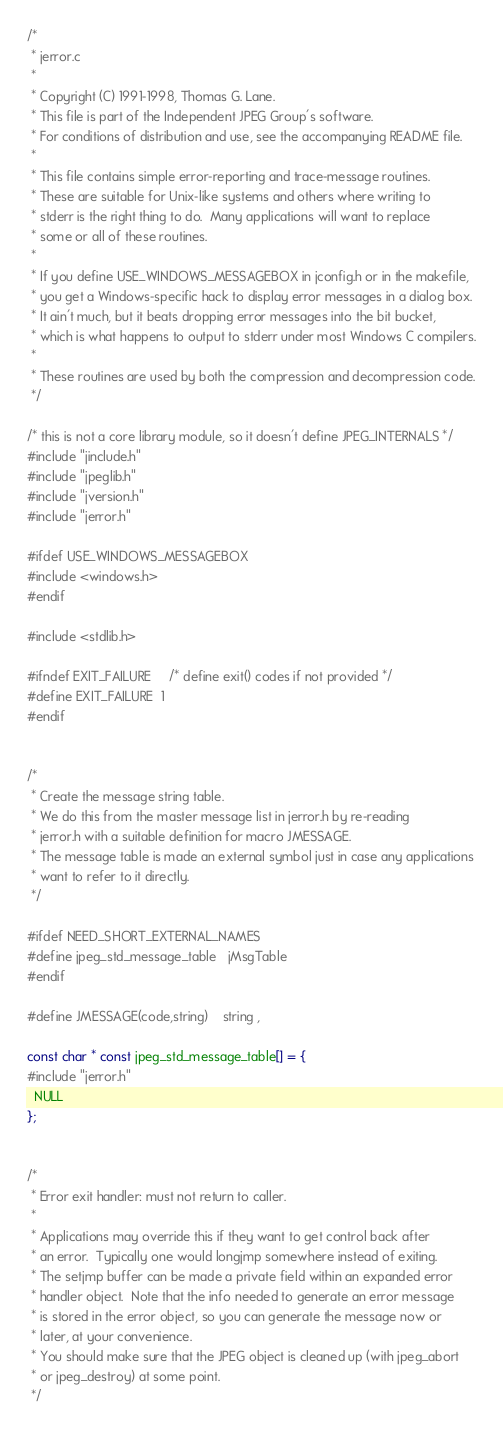Convert code to text. <code><loc_0><loc_0><loc_500><loc_500><_C_>/*
 * jerror.c
 *
 * Copyright (C) 1991-1998, Thomas G. Lane.
 * This file is part of the Independent JPEG Group's software.
 * For conditions of distribution and use, see the accompanying README file.
 *
 * This file contains simple error-reporting and trace-message routines.
 * These are suitable for Unix-like systems and others where writing to
 * stderr is the right thing to do.  Many applications will want to replace
 * some or all of these routines.
 *
 * If you define USE_WINDOWS_MESSAGEBOX in jconfig.h or in the makefile,
 * you get a Windows-specific hack to display error messages in a dialog box.
 * It ain't much, but it beats dropping error messages into the bit bucket,
 * which is what happens to output to stderr under most Windows C compilers.
 *
 * These routines are used by both the compression and decompression code.
 */

/* this is not a core library module, so it doesn't define JPEG_INTERNALS */
#include "jinclude.h"
#include "jpeglib.h"
#include "jversion.h"
#include "jerror.h"

#ifdef USE_WINDOWS_MESSAGEBOX
#include <windows.h>
#endif

#include <stdlib.h>

#ifndef EXIT_FAILURE		/* define exit() codes if not provided */
#define EXIT_FAILURE  1
#endif


/*
 * Create the message string table.
 * We do this from the master message list in jerror.h by re-reading
 * jerror.h with a suitable definition for macro JMESSAGE.
 * The message table is made an external symbol just in case any applications
 * want to refer to it directly.
 */

#ifdef NEED_SHORT_EXTERNAL_NAMES
#define jpeg_std_message_table	jMsgTable
#endif

#define JMESSAGE(code,string)	string ,

const char * const jpeg_std_message_table[] = {
#include "jerror.h"
  NULL
};


/*
 * Error exit handler: must not return to caller.
 *
 * Applications may override this if they want to get control back after
 * an error.  Typically one would longjmp somewhere instead of exiting.
 * The setjmp buffer can be made a private field within an expanded error
 * handler object.  Note that the info needed to generate an error message
 * is stored in the error object, so you can generate the message now or
 * later, at your convenience.
 * You should make sure that the JPEG object is cleaned up (with jpeg_abort
 * or jpeg_destroy) at some point.
 */
</code> 